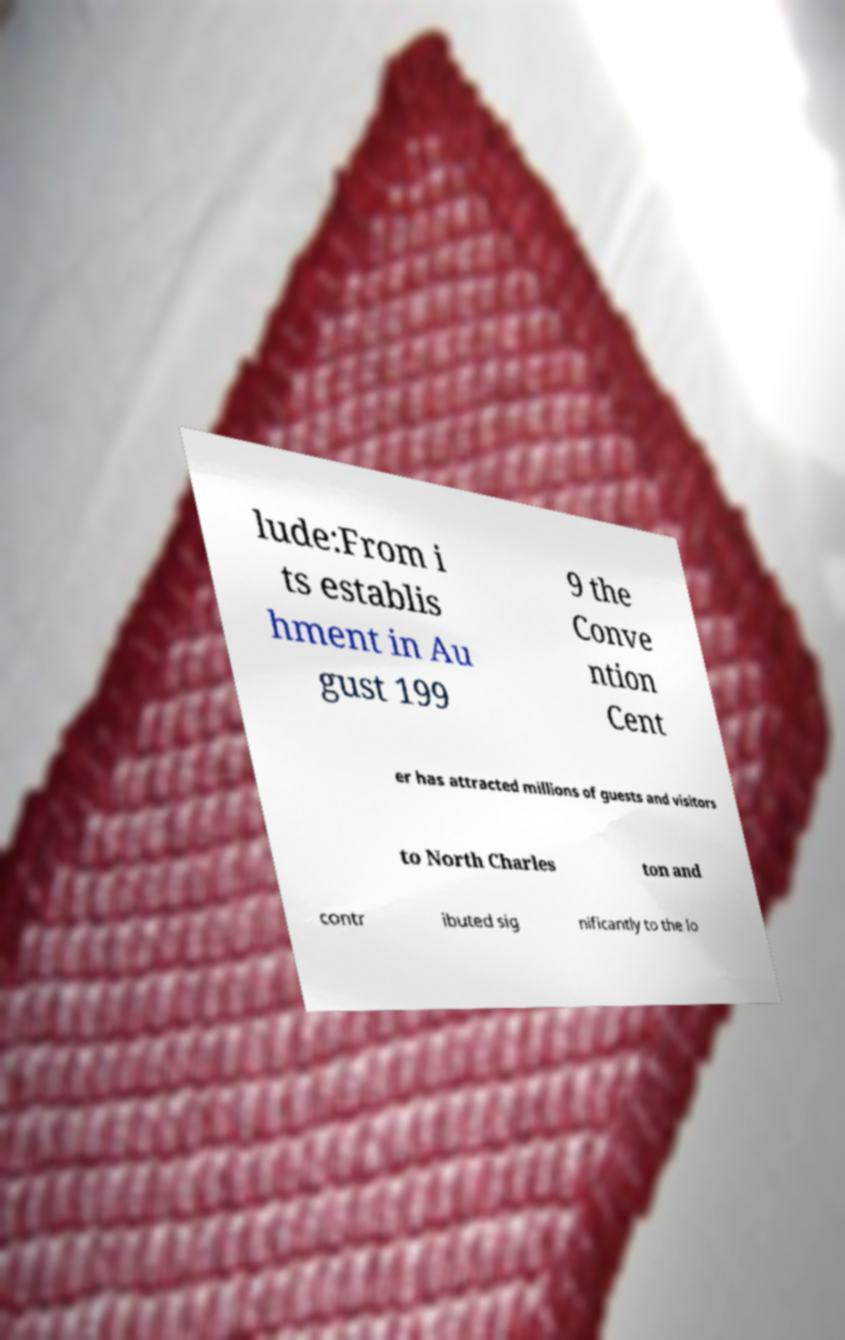Please identify and transcribe the text found in this image. lude:From i ts establis hment in Au gust 199 9 the Conve ntion Cent er has attracted millions of guests and visitors to North Charles ton and contr ibuted sig nificantly to the lo 